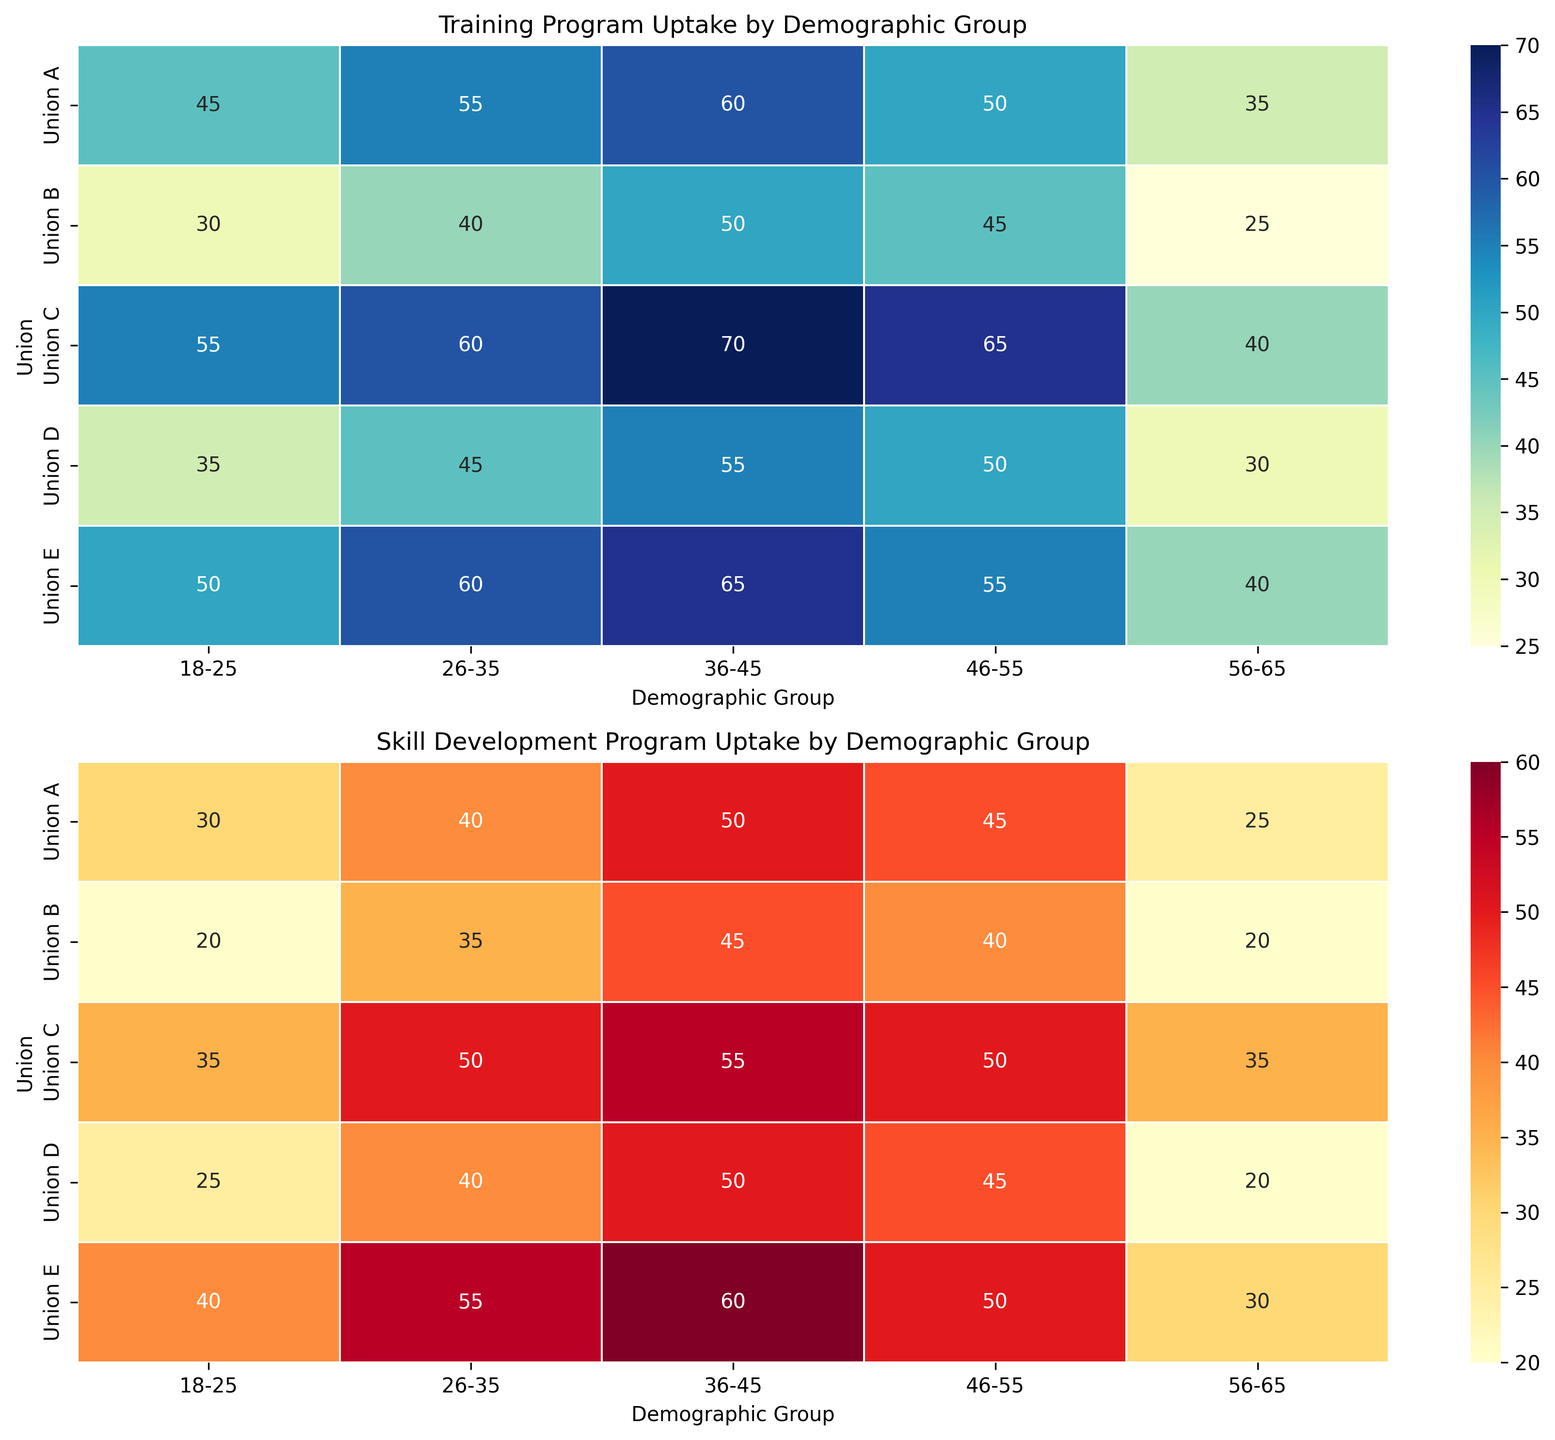Which union has the highest training program uptake for the 36-45 demographic group? Look at the top subplot for the '36-45' column. Union C has the highest value which is 70.
Answer: Union C Which union has the lowest skill development program uptake for the 56-65 demographic group? Look at the bottom subplot for the '56-65' column. Union B has the lowest value which is 20.
Answer: Union B What is the difference in training program uptake between Union A and Union E for the 26-35 demographic group? Look at the top subplot for the '26-35' column. Union A has a value of 55, and Union E has a value of 60. The difference is 60 - 55 = 5.
Answer: 5 Which demographic group saw the highest uptake in both training and skill development programs within Union C? Look at both plots for Union C rows. For training, the highest is 70 (36-45), and for skill development, the highest is 55 (36-45). Both are in the 36-45 demographic group.
Answer: 36-45 For Union B, what is the average skill development program uptake across all demographic groups? Look at the bottom subplot for the Union B row. Average the values: (20 + 35 + 45 + 40 + 20) / 5. This equals 160 / 5 = 32.
Answer: 32 Are there any unions where the training program uptake for the 18-25 demographic group is higher than for the 46-55 demographic group? Look at the top subplot, check '18-25' and '46-55' columns across all rows. Union C has higher in '18-25' (55) than '46-55' (50) and Union E has higher in '18-25' (50) than '46-55' (45).
Answer: Union C, Union E Compare the color intensities between the 26-35 demographic group for Union D in both programs. Which program has a higher uptake? Compare both subplot colors for Union D in the '26-35' column. The bottom subplot (skill development) has a higher intensity, indicating higher uptake (40) than the training program (45).
Answer: Training program Is there any union where the training program uptake is equal for the 46-55 and 56-65 demographic groups? Look at the top subplot, compare values in '46-55' and '56-65' columns for each row. None of the values are equal.
Answer: No Which union shows the biggest difference in training program uptake compared to skill development program uptake for the 26-35 demographic group? Compare differences between values in '26-35' columns of both plots for each row. Differences are: A (55-40=15), B (40-35=5), C (60-50=10), D (45-40=5), E (60-55=5). The biggest difference is for Union A, which is 15.
Answer: Union A For the 46-55 demographic group, how does the average uptake of training programs compare to skill development programs across all unions? Calculate average uptakes for '46-55' across rows for both plots: Training: (50+45+65+50+55)/5 = 265/5 = 53. Skill development: (45+40+50+45+50)/5 = 230/5 = 46. The training program uptake average is higher than the skill development program uptake average.
Answer: Training program on average is higher 